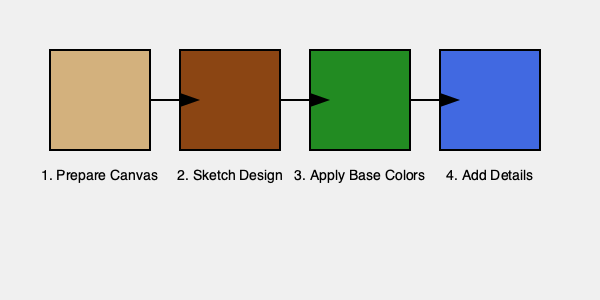What is the correct sequence of steps in creating a traditional indigenous painting technique, as shown in the diagram? The diagram illustrates the traditional indigenous painting technique in four main steps:

1. Prepare Canvas: This is represented by the first box, showing a light brown color symbolizing a prepared canvas or surface. This step involves selecting and preparing the appropriate surface for the painting, which could be bark, hide, or a specially treated canvas.

2. Sketch Design: The second box shows a darker brown color, representing the initial sketch or outline of the design. In this step, the artist would typically draw the main elements of the composition using traditional tools or techniques.

3. Apply Base Colors: The third box is colored green, symbolizing the application of base colors. This step involves laying down the primary colors of the design, often using natural pigments or traditional paint materials.

4. Add Details: The final box is blue, representing the addition of intricate details and finishing touches. This step involves adding fine lines, patterns, and additional elements that bring depth and cultural significance to the artwork.

The arrows between the boxes indicate the progression from one step to the next, emphasizing the sequential nature of the process.

This sequence is typical in many traditional indigenous painting techniques, though specific practices may vary among different cultures and individual artists.
Answer: Prepare Canvas, Sketch Design, Apply Base Colors, Add Details 